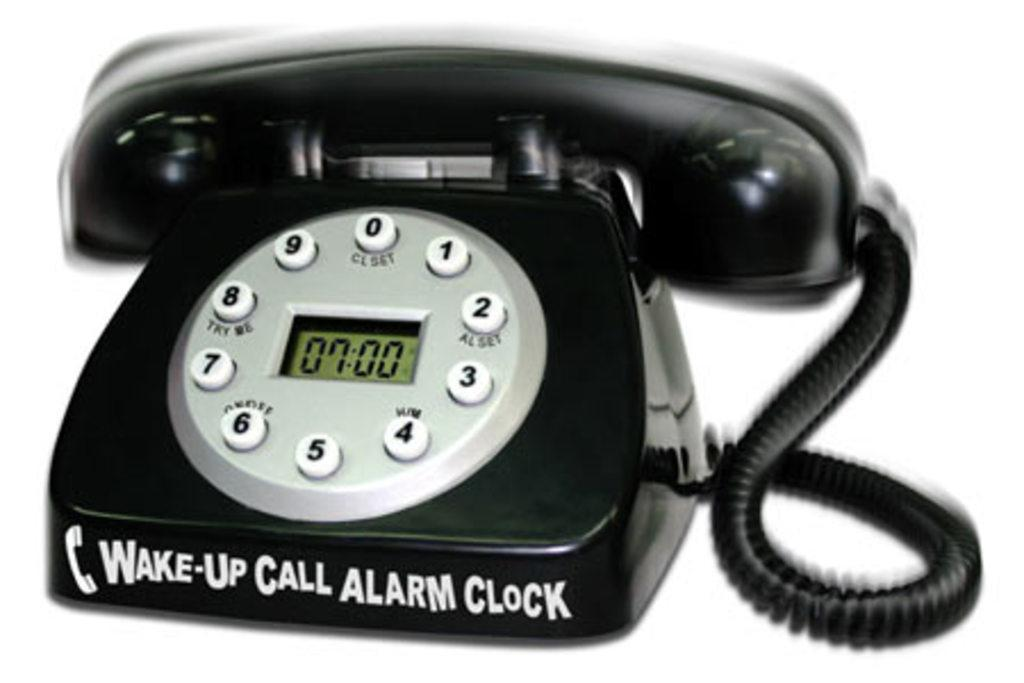<image>
Offer a succinct explanation of the picture presented. wake up call alarm clock written on a house phone 